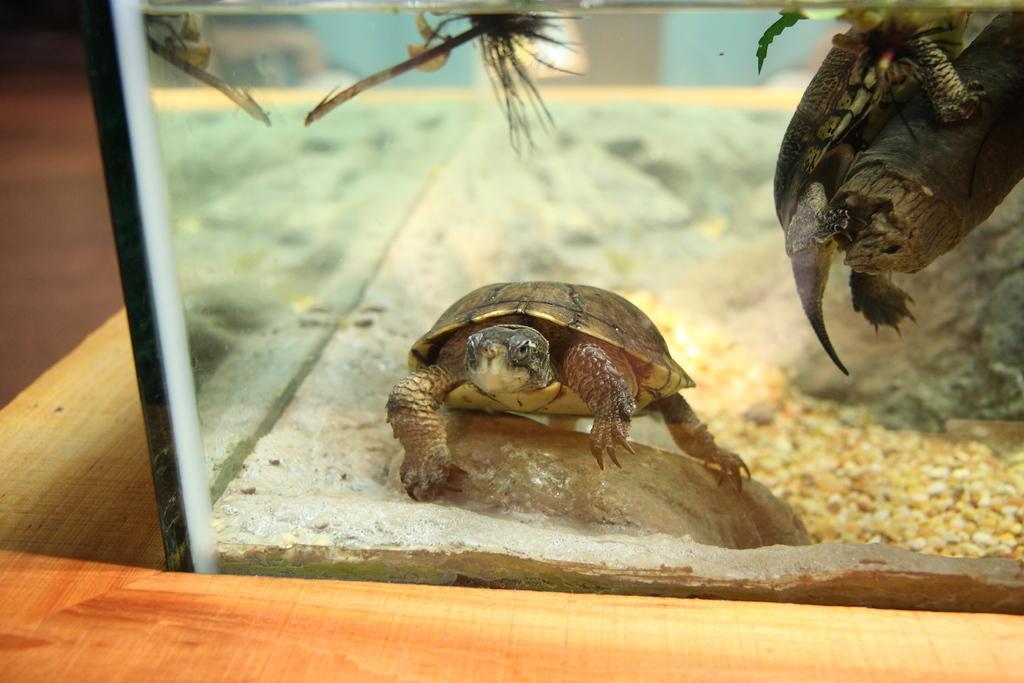Describe this image in one or two sentences. In the middle of the image, there is a tortoise walking on a rock. Beside this rock, there are stones and a wall. This wall is attached the glass windows. Beside these glass windows, there is a wooden surface. And the background is blurred. 